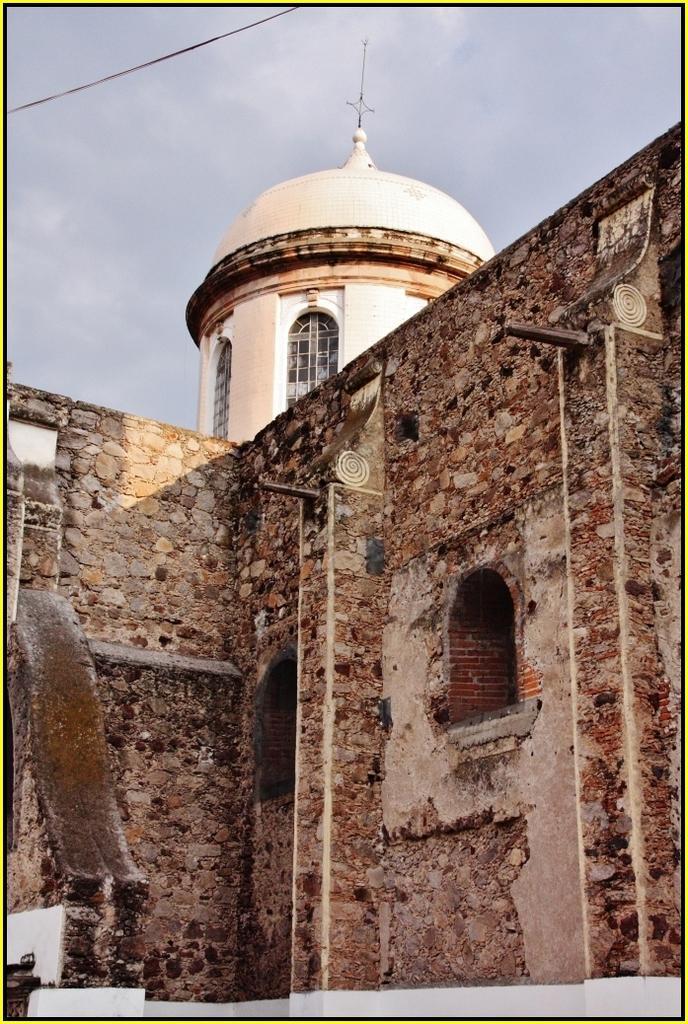In one or two sentences, can you explain what this image depicts? In this image I can see a building,windows and brick wall. The sky is in blue and white color. 